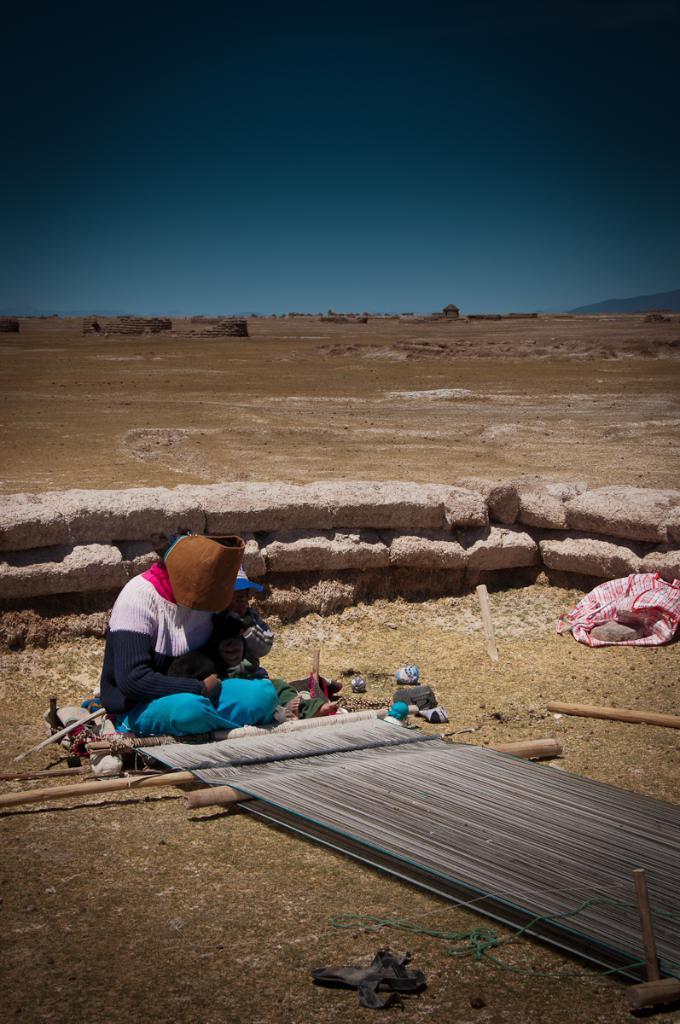Can you describe this image briefly? In this image we can see a person is sitting on the floor. In front of the person cloth like thing is there which is attached to the bamboos. Background of the image vast land is there. At the top of the image sky, is there. Right side of the image one cloth and stone are there. Behind the person small boundary is there. 